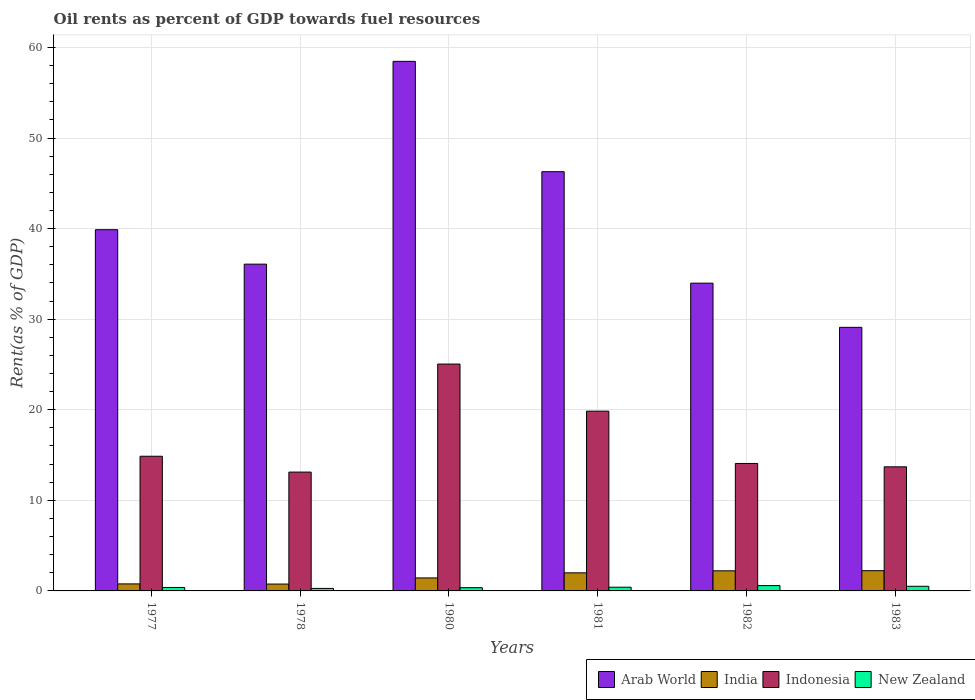Are the number of bars per tick equal to the number of legend labels?
Your answer should be very brief. Yes. How many bars are there on the 5th tick from the left?
Ensure brevity in your answer.  4. How many bars are there on the 4th tick from the right?
Your answer should be compact. 4. In how many cases, is the number of bars for a given year not equal to the number of legend labels?
Offer a very short reply. 0. What is the oil rent in Indonesia in 1982?
Provide a short and direct response. 14.07. Across all years, what is the maximum oil rent in India?
Ensure brevity in your answer.  2.23. Across all years, what is the minimum oil rent in Arab World?
Offer a very short reply. 29.1. In which year was the oil rent in Arab World maximum?
Offer a terse response. 1980. In which year was the oil rent in New Zealand minimum?
Provide a short and direct response. 1978. What is the total oil rent in New Zealand in the graph?
Give a very brief answer. 2.53. What is the difference between the oil rent in Indonesia in 1977 and that in 1980?
Offer a terse response. -10.18. What is the difference between the oil rent in India in 1981 and the oil rent in Arab World in 1982?
Your response must be concise. -31.98. What is the average oil rent in India per year?
Your response must be concise. 1.57. In the year 1978, what is the difference between the oil rent in New Zealand and oil rent in India?
Keep it short and to the point. -0.48. What is the ratio of the oil rent in Indonesia in 1978 to that in 1982?
Make the answer very short. 0.93. Is the oil rent in Arab World in 1977 less than that in 1978?
Your response must be concise. No. Is the difference between the oil rent in New Zealand in 1980 and 1982 greater than the difference between the oil rent in India in 1980 and 1982?
Ensure brevity in your answer.  Yes. What is the difference between the highest and the second highest oil rent in Arab World?
Ensure brevity in your answer.  12.18. What is the difference between the highest and the lowest oil rent in New Zealand?
Provide a succinct answer. 0.31. In how many years, is the oil rent in Indonesia greater than the average oil rent in Indonesia taken over all years?
Offer a very short reply. 2. Is it the case that in every year, the sum of the oil rent in Indonesia and oil rent in New Zealand is greater than the sum of oil rent in Arab World and oil rent in India?
Offer a terse response. Yes. What does the 4th bar from the left in 1983 represents?
Your answer should be very brief. New Zealand. What does the 2nd bar from the right in 1978 represents?
Your answer should be very brief. Indonesia. Is it the case that in every year, the sum of the oil rent in New Zealand and oil rent in India is greater than the oil rent in Indonesia?
Make the answer very short. No. Are all the bars in the graph horizontal?
Ensure brevity in your answer.  No. Are the values on the major ticks of Y-axis written in scientific E-notation?
Your answer should be very brief. No. Does the graph contain any zero values?
Offer a very short reply. No. How many legend labels are there?
Give a very brief answer. 4. How are the legend labels stacked?
Provide a short and direct response. Horizontal. What is the title of the graph?
Provide a succinct answer. Oil rents as percent of GDP towards fuel resources. Does "Kazakhstan" appear as one of the legend labels in the graph?
Make the answer very short. No. What is the label or title of the Y-axis?
Your answer should be very brief. Rent(as % of GDP). What is the Rent(as % of GDP) in Arab World in 1977?
Provide a short and direct response. 39.88. What is the Rent(as % of GDP) of India in 1977?
Your response must be concise. 0.77. What is the Rent(as % of GDP) of Indonesia in 1977?
Your answer should be compact. 14.87. What is the Rent(as % of GDP) in New Zealand in 1977?
Ensure brevity in your answer.  0.38. What is the Rent(as % of GDP) of Arab World in 1978?
Offer a very short reply. 36.08. What is the Rent(as % of GDP) in India in 1978?
Ensure brevity in your answer.  0.76. What is the Rent(as % of GDP) of Indonesia in 1978?
Your answer should be compact. 13.12. What is the Rent(as % of GDP) of New Zealand in 1978?
Offer a very short reply. 0.28. What is the Rent(as % of GDP) of Arab World in 1980?
Your response must be concise. 58.46. What is the Rent(as % of GDP) of India in 1980?
Offer a terse response. 1.43. What is the Rent(as % of GDP) in Indonesia in 1980?
Provide a short and direct response. 25.05. What is the Rent(as % of GDP) in New Zealand in 1980?
Provide a short and direct response. 0.36. What is the Rent(as % of GDP) in Arab World in 1981?
Offer a terse response. 46.28. What is the Rent(as % of GDP) in India in 1981?
Your response must be concise. 2. What is the Rent(as % of GDP) of Indonesia in 1981?
Ensure brevity in your answer.  19.85. What is the Rent(as % of GDP) in New Zealand in 1981?
Make the answer very short. 0.41. What is the Rent(as % of GDP) of Arab World in 1982?
Keep it short and to the point. 33.98. What is the Rent(as % of GDP) of India in 1982?
Your answer should be compact. 2.22. What is the Rent(as % of GDP) of Indonesia in 1982?
Make the answer very short. 14.07. What is the Rent(as % of GDP) of New Zealand in 1982?
Offer a terse response. 0.59. What is the Rent(as % of GDP) of Arab World in 1983?
Ensure brevity in your answer.  29.1. What is the Rent(as % of GDP) in India in 1983?
Keep it short and to the point. 2.23. What is the Rent(as % of GDP) of Indonesia in 1983?
Keep it short and to the point. 13.7. What is the Rent(as % of GDP) of New Zealand in 1983?
Your response must be concise. 0.51. Across all years, what is the maximum Rent(as % of GDP) of Arab World?
Your answer should be compact. 58.46. Across all years, what is the maximum Rent(as % of GDP) in India?
Give a very brief answer. 2.23. Across all years, what is the maximum Rent(as % of GDP) of Indonesia?
Your response must be concise. 25.05. Across all years, what is the maximum Rent(as % of GDP) in New Zealand?
Offer a terse response. 0.59. Across all years, what is the minimum Rent(as % of GDP) in Arab World?
Offer a terse response. 29.1. Across all years, what is the minimum Rent(as % of GDP) of India?
Your answer should be compact. 0.76. Across all years, what is the minimum Rent(as % of GDP) of Indonesia?
Provide a short and direct response. 13.12. Across all years, what is the minimum Rent(as % of GDP) of New Zealand?
Your answer should be very brief. 0.28. What is the total Rent(as % of GDP) of Arab World in the graph?
Give a very brief answer. 243.77. What is the total Rent(as % of GDP) in India in the graph?
Offer a terse response. 9.41. What is the total Rent(as % of GDP) in Indonesia in the graph?
Give a very brief answer. 100.65. What is the total Rent(as % of GDP) in New Zealand in the graph?
Provide a short and direct response. 2.53. What is the difference between the Rent(as % of GDP) in Arab World in 1977 and that in 1978?
Make the answer very short. 3.8. What is the difference between the Rent(as % of GDP) in India in 1977 and that in 1978?
Offer a very short reply. 0.02. What is the difference between the Rent(as % of GDP) in Indonesia in 1977 and that in 1978?
Your response must be concise. 1.75. What is the difference between the Rent(as % of GDP) of New Zealand in 1977 and that in 1978?
Make the answer very short. 0.11. What is the difference between the Rent(as % of GDP) of Arab World in 1977 and that in 1980?
Your answer should be compact. -18.58. What is the difference between the Rent(as % of GDP) in India in 1977 and that in 1980?
Provide a short and direct response. -0.66. What is the difference between the Rent(as % of GDP) of Indonesia in 1977 and that in 1980?
Make the answer very short. -10.18. What is the difference between the Rent(as % of GDP) of New Zealand in 1977 and that in 1980?
Offer a terse response. 0.02. What is the difference between the Rent(as % of GDP) of Arab World in 1977 and that in 1981?
Provide a succinct answer. -6.4. What is the difference between the Rent(as % of GDP) in India in 1977 and that in 1981?
Provide a short and direct response. -1.22. What is the difference between the Rent(as % of GDP) in Indonesia in 1977 and that in 1981?
Your answer should be very brief. -4.98. What is the difference between the Rent(as % of GDP) of New Zealand in 1977 and that in 1981?
Offer a terse response. -0.03. What is the difference between the Rent(as % of GDP) of Arab World in 1977 and that in 1982?
Provide a short and direct response. 5.9. What is the difference between the Rent(as % of GDP) in India in 1977 and that in 1982?
Your answer should be very brief. -1.44. What is the difference between the Rent(as % of GDP) in Indonesia in 1977 and that in 1982?
Offer a terse response. 0.8. What is the difference between the Rent(as % of GDP) in New Zealand in 1977 and that in 1982?
Offer a terse response. -0.21. What is the difference between the Rent(as % of GDP) in Arab World in 1977 and that in 1983?
Offer a very short reply. 10.78. What is the difference between the Rent(as % of GDP) of India in 1977 and that in 1983?
Provide a succinct answer. -1.46. What is the difference between the Rent(as % of GDP) of Indonesia in 1977 and that in 1983?
Offer a terse response. 1.17. What is the difference between the Rent(as % of GDP) in New Zealand in 1977 and that in 1983?
Offer a very short reply. -0.13. What is the difference between the Rent(as % of GDP) of Arab World in 1978 and that in 1980?
Your answer should be very brief. -22.39. What is the difference between the Rent(as % of GDP) of India in 1978 and that in 1980?
Offer a terse response. -0.68. What is the difference between the Rent(as % of GDP) in Indonesia in 1978 and that in 1980?
Offer a terse response. -11.93. What is the difference between the Rent(as % of GDP) of New Zealand in 1978 and that in 1980?
Offer a terse response. -0.08. What is the difference between the Rent(as % of GDP) of Arab World in 1978 and that in 1981?
Keep it short and to the point. -10.21. What is the difference between the Rent(as % of GDP) of India in 1978 and that in 1981?
Provide a succinct answer. -1.24. What is the difference between the Rent(as % of GDP) in Indonesia in 1978 and that in 1981?
Your answer should be compact. -6.73. What is the difference between the Rent(as % of GDP) in New Zealand in 1978 and that in 1981?
Provide a succinct answer. -0.13. What is the difference between the Rent(as % of GDP) in Arab World in 1978 and that in 1982?
Keep it short and to the point. 2.1. What is the difference between the Rent(as % of GDP) in India in 1978 and that in 1982?
Offer a very short reply. -1.46. What is the difference between the Rent(as % of GDP) in Indonesia in 1978 and that in 1982?
Make the answer very short. -0.95. What is the difference between the Rent(as % of GDP) of New Zealand in 1978 and that in 1982?
Your response must be concise. -0.31. What is the difference between the Rent(as % of GDP) in Arab World in 1978 and that in 1983?
Give a very brief answer. 6.98. What is the difference between the Rent(as % of GDP) in India in 1978 and that in 1983?
Ensure brevity in your answer.  -1.47. What is the difference between the Rent(as % of GDP) in Indonesia in 1978 and that in 1983?
Your answer should be very brief. -0.58. What is the difference between the Rent(as % of GDP) of New Zealand in 1978 and that in 1983?
Provide a succinct answer. -0.24. What is the difference between the Rent(as % of GDP) in Arab World in 1980 and that in 1981?
Your response must be concise. 12.18. What is the difference between the Rent(as % of GDP) of India in 1980 and that in 1981?
Your response must be concise. -0.56. What is the difference between the Rent(as % of GDP) of Indonesia in 1980 and that in 1981?
Offer a very short reply. 5.2. What is the difference between the Rent(as % of GDP) of New Zealand in 1980 and that in 1981?
Your answer should be compact. -0.05. What is the difference between the Rent(as % of GDP) of Arab World in 1980 and that in 1982?
Your answer should be very brief. 24.49. What is the difference between the Rent(as % of GDP) in India in 1980 and that in 1982?
Your answer should be very brief. -0.79. What is the difference between the Rent(as % of GDP) of Indonesia in 1980 and that in 1982?
Give a very brief answer. 10.97. What is the difference between the Rent(as % of GDP) in New Zealand in 1980 and that in 1982?
Make the answer very short. -0.23. What is the difference between the Rent(as % of GDP) in Arab World in 1980 and that in 1983?
Give a very brief answer. 29.36. What is the difference between the Rent(as % of GDP) in India in 1980 and that in 1983?
Offer a terse response. -0.8. What is the difference between the Rent(as % of GDP) in Indonesia in 1980 and that in 1983?
Offer a very short reply. 11.35. What is the difference between the Rent(as % of GDP) in New Zealand in 1980 and that in 1983?
Give a very brief answer. -0.15. What is the difference between the Rent(as % of GDP) of Arab World in 1981 and that in 1982?
Your response must be concise. 12.31. What is the difference between the Rent(as % of GDP) of India in 1981 and that in 1982?
Provide a short and direct response. -0.22. What is the difference between the Rent(as % of GDP) in Indonesia in 1981 and that in 1982?
Your response must be concise. 5.77. What is the difference between the Rent(as % of GDP) in New Zealand in 1981 and that in 1982?
Make the answer very short. -0.18. What is the difference between the Rent(as % of GDP) in Arab World in 1981 and that in 1983?
Provide a short and direct response. 17.18. What is the difference between the Rent(as % of GDP) of India in 1981 and that in 1983?
Give a very brief answer. -0.24. What is the difference between the Rent(as % of GDP) of Indonesia in 1981 and that in 1983?
Give a very brief answer. 6.14. What is the difference between the Rent(as % of GDP) in New Zealand in 1981 and that in 1983?
Give a very brief answer. -0.1. What is the difference between the Rent(as % of GDP) in Arab World in 1982 and that in 1983?
Offer a terse response. 4.88. What is the difference between the Rent(as % of GDP) of India in 1982 and that in 1983?
Ensure brevity in your answer.  -0.01. What is the difference between the Rent(as % of GDP) of Indonesia in 1982 and that in 1983?
Offer a very short reply. 0.37. What is the difference between the Rent(as % of GDP) in New Zealand in 1982 and that in 1983?
Your answer should be very brief. 0.08. What is the difference between the Rent(as % of GDP) in Arab World in 1977 and the Rent(as % of GDP) in India in 1978?
Your answer should be very brief. 39.12. What is the difference between the Rent(as % of GDP) of Arab World in 1977 and the Rent(as % of GDP) of Indonesia in 1978?
Make the answer very short. 26.76. What is the difference between the Rent(as % of GDP) of Arab World in 1977 and the Rent(as % of GDP) of New Zealand in 1978?
Make the answer very short. 39.6. What is the difference between the Rent(as % of GDP) of India in 1977 and the Rent(as % of GDP) of Indonesia in 1978?
Give a very brief answer. -12.35. What is the difference between the Rent(as % of GDP) in India in 1977 and the Rent(as % of GDP) in New Zealand in 1978?
Provide a succinct answer. 0.5. What is the difference between the Rent(as % of GDP) of Indonesia in 1977 and the Rent(as % of GDP) of New Zealand in 1978?
Offer a very short reply. 14.59. What is the difference between the Rent(as % of GDP) of Arab World in 1977 and the Rent(as % of GDP) of India in 1980?
Ensure brevity in your answer.  38.45. What is the difference between the Rent(as % of GDP) of Arab World in 1977 and the Rent(as % of GDP) of Indonesia in 1980?
Make the answer very short. 14.83. What is the difference between the Rent(as % of GDP) of Arab World in 1977 and the Rent(as % of GDP) of New Zealand in 1980?
Offer a very short reply. 39.52. What is the difference between the Rent(as % of GDP) in India in 1977 and the Rent(as % of GDP) in Indonesia in 1980?
Offer a terse response. -24.27. What is the difference between the Rent(as % of GDP) in India in 1977 and the Rent(as % of GDP) in New Zealand in 1980?
Your answer should be compact. 0.42. What is the difference between the Rent(as % of GDP) of Indonesia in 1977 and the Rent(as % of GDP) of New Zealand in 1980?
Offer a terse response. 14.51. What is the difference between the Rent(as % of GDP) of Arab World in 1977 and the Rent(as % of GDP) of India in 1981?
Offer a very short reply. 37.88. What is the difference between the Rent(as % of GDP) in Arab World in 1977 and the Rent(as % of GDP) in Indonesia in 1981?
Your response must be concise. 20.03. What is the difference between the Rent(as % of GDP) in Arab World in 1977 and the Rent(as % of GDP) in New Zealand in 1981?
Offer a very short reply. 39.47. What is the difference between the Rent(as % of GDP) of India in 1977 and the Rent(as % of GDP) of Indonesia in 1981?
Give a very brief answer. -19.07. What is the difference between the Rent(as % of GDP) in India in 1977 and the Rent(as % of GDP) in New Zealand in 1981?
Provide a short and direct response. 0.36. What is the difference between the Rent(as % of GDP) of Indonesia in 1977 and the Rent(as % of GDP) of New Zealand in 1981?
Make the answer very short. 14.46. What is the difference between the Rent(as % of GDP) in Arab World in 1977 and the Rent(as % of GDP) in India in 1982?
Your answer should be compact. 37.66. What is the difference between the Rent(as % of GDP) of Arab World in 1977 and the Rent(as % of GDP) of Indonesia in 1982?
Ensure brevity in your answer.  25.81. What is the difference between the Rent(as % of GDP) in Arab World in 1977 and the Rent(as % of GDP) in New Zealand in 1982?
Your answer should be compact. 39.29. What is the difference between the Rent(as % of GDP) of India in 1977 and the Rent(as % of GDP) of Indonesia in 1982?
Offer a very short reply. -13.3. What is the difference between the Rent(as % of GDP) in India in 1977 and the Rent(as % of GDP) in New Zealand in 1982?
Provide a succinct answer. 0.19. What is the difference between the Rent(as % of GDP) in Indonesia in 1977 and the Rent(as % of GDP) in New Zealand in 1982?
Make the answer very short. 14.28. What is the difference between the Rent(as % of GDP) in Arab World in 1977 and the Rent(as % of GDP) in India in 1983?
Provide a short and direct response. 37.65. What is the difference between the Rent(as % of GDP) of Arab World in 1977 and the Rent(as % of GDP) of Indonesia in 1983?
Your answer should be compact. 26.18. What is the difference between the Rent(as % of GDP) in Arab World in 1977 and the Rent(as % of GDP) in New Zealand in 1983?
Keep it short and to the point. 39.37. What is the difference between the Rent(as % of GDP) in India in 1977 and the Rent(as % of GDP) in Indonesia in 1983?
Keep it short and to the point. -12.93. What is the difference between the Rent(as % of GDP) of India in 1977 and the Rent(as % of GDP) of New Zealand in 1983?
Your answer should be very brief. 0.26. What is the difference between the Rent(as % of GDP) in Indonesia in 1977 and the Rent(as % of GDP) in New Zealand in 1983?
Provide a short and direct response. 14.36. What is the difference between the Rent(as % of GDP) in Arab World in 1978 and the Rent(as % of GDP) in India in 1980?
Make the answer very short. 34.64. What is the difference between the Rent(as % of GDP) in Arab World in 1978 and the Rent(as % of GDP) in Indonesia in 1980?
Your answer should be very brief. 11.03. What is the difference between the Rent(as % of GDP) of Arab World in 1978 and the Rent(as % of GDP) of New Zealand in 1980?
Provide a short and direct response. 35.72. What is the difference between the Rent(as % of GDP) in India in 1978 and the Rent(as % of GDP) in Indonesia in 1980?
Ensure brevity in your answer.  -24.29. What is the difference between the Rent(as % of GDP) in India in 1978 and the Rent(as % of GDP) in New Zealand in 1980?
Offer a very short reply. 0.4. What is the difference between the Rent(as % of GDP) of Indonesia in 1978 and the Rent(as % of GDP) of New Zealand in 1980?
Give a very brief answer. 12.76. What is the difference between the Rent(as % of GDP) of Arab World in 1978 and the Rent(as % of GDP) of India in 1981?
Make the answer very short. 34.08. What is the difference between the Rent(as % of GDP) in Arab World in 1978 and the Rent(as % of GDP) in Indonesia in 1981?
Offer a terse response. 16.23. What is the difference between the Rent(as % of GDP) in Arab World in 1978 and the Rent(as % of GDP) in New Zealand in 1981?
Offer a terse response. 35.66. What is the difference between the Rent(as % of GDP) of India in 1978 and the Rent(as % of GDP) of Indonesia in 1981?
Keep it short and to the point. -19.09. What is the difference between the Rent(as % of GDP) of India in 1978 and the Rent(as % of GDP) of New Zealand in 1981?
Provide a short and direct response. 0.35. What is the difference between the Rent(as % of GDP) in Indonesia in 1978 and the Rent(as % of GDP) in New Zealand in 1981?
Provide a succinct answer. 12.71. What is the difference between the Rent(as % of GDP) in Arab World in 1978 and the Rent(as % of GDP) in India in 1982?
Give a very brief answer. 33.86. What is the difference between the Rent(as % of GDP) in Arab World in 1978 and the Rent(as % of GDP) in Indonesia in 1982?
Offer a terse response. 22. What is the difference between the Rent(as % of GDP) in Arab World in 1978 and the Rent(as % of GDP) in New Zealand in 1982?
Offer a terse response. 35.49. What is the difference between the Rent(as % of GDP) in India in 1978 and the Rent(as % of GDP) in Indonesia in 1982?
Offer a terse response. -13.31. What is the difference between the Rent(as % of GDP) of India in 1978 and the Rent(as % of GDP) of New Zealand in 1982?
Offer a very short reply. 0.17. What is the difference between the Rent(as % of GDP) in Indonesia in 1978 and the Rent(as % of GDP) in New Zealand in 1982?
Your answer should be very brief. 12.53. What is the difference between the Rent(as % of GDP) in Arab World in 1978 and the Rent(as % of GDP) in India in 1983?
Keep it short and to the point. 33.84. What is the difference between the Rent(as % of GDP) of Arab World in 1978 and the Rent(as % of GDP) of Indonesia in 1983?
Make the answer very short. 22.37. What is the difference between the Rent(as % of GDP) in Arab World in 1978 and the Rent(as % of GDP) in New Zealand in 1983?
Give a very brief answer. 35.56. What is the difference between the Rent(as % of GDP) of India in 1978 and the Rent(as % of GDP) of Indonesia in 1983?
Provide a short and direct response. -12.94. What is the difference between the Rent(as % of GDP) in India in 1978 and the Rent(as % of GDP) in New Zealand in 1983?
Your answer should be very brief. 0.25. What is the difference between the Rent(as % of GDP) of Indonesia in 1978 and the Rent(as % of GDP) of New Zealand in 1983?
Offer a terse response. 12.61. What is the difference between the Rent(as % of GDP) of Arab World in 1980 and the Rent(as % of GDP) of India in 1981?
Keep it short and to the point. 56.47. What is the difference between the Rent(as % of GDP) of Arab World in 1980 and the Rent(as % of GDP) of Indonesia in 1981?
Give a very brief answer. 38.62. What is the difference between the Rent(as % of GDP) of Arab World in 1980 and the Rent(as % of GDP) of New Zealand in 1981?
Your response must be concise. 58.05. What is the difference between the Rent(as % of GDP) in India in 1980 and the Rent(as % of GDP) in Indonesia in 1981?
Your response must be concise. -18.41. What is the difference between the Rent(as % of GDP) in India in 1980 and the Rent(as % of GDP) in New Zealand in 1981?
Make the answer very short. 1.02. What is the difference between the Rent(as % of GDP) in Indonesia in 1980 and the Rent(as % of GDP) in New Zealand in 1981?
Give a very brief answer. 24.64. What is the difference between the Rent(as % of GDP) of Arab World in 1980 and the Rent(as % of GDP) of India in 1982?
Give a very brief answer. 56.24. What is the difference between the Rent(as % of GDP) of Arab World in 1980 and the Rent(as % of GDP) of Indonesia in 1982?
Give a very brief answer. 44.39. What is the difference between the Rent(as % of GDP) of Arab World in 1980 and the Rent(as % of GDP) of New Zealand in 1982?
Give a very brief answer. 57.88. What is the difference between the Rent(as % of GDP) in India in 1980 and the Rent(as % of GDP) in Indonesia in 1982?
Make the answer very short. -12.64. What is the difference between the Rent(as % of GDP) in India in 1980 and the Rent(as % of GDP) in New Zealand in 1982?
Give a very brief answer. 0.84. What is the difference between the Rent(as % of GDP) of Indonesia in 1980 and the Rent(as % of GDP) of New Zealand in 1982?
Keep it short and to the point. 24.46. What is the difference between the Rent(as % of GDP) in Arab World in 1980 and the Rent(as % of GDP) in India in 1983?
Offer a terse response. 56.23. What is the difference between the Rent(as % of GDP) in Arab World in 1980 and the Rent(as % of GDP) in Indonesia in 1983?
Provide a short and direct response. 44.76. What is the difference between the Rent(as % of GDP) of Arab World in 1980 and the Rent(as % of GDP) of New Zealand in 1983?
Offer a very short reply. 57.95. What is the difference between the Rent(as % of GDP) in India in 1980 and the Rent(as % of GDP) in Indonesia in 1983?
Your answer should be compact. -12.27. What is the difference between the Rent(as % of GDP) of India in 1980 and the Rent(as % of GDP) of New Zealand in 1983?
Your answer should be compact. 0.92. What is the difference between the Rent(as % of GDP) in Indonesia in 1980 and the Rent(as % of GDP) in New Zealand in 1983?
Your response must be concise. 24.53. What is the difference between the Rent(as % of GDP) in Arab World in 1981 and the Rent(as % of GDP) in India in 1982?
Ensure brevity in your answer.  44.06. What is the difference between the Rent(as % of GDP) in Arab World in 1981 and the Rent(as % of GDP) in Indonesia in 1982?
Keep it short and to the point. 32.21. What is the difference between the Rent(as % of GDP) of Arab World in 1981 and the Rent(as % of GDP) of New Zealand in 1982?
Make the answer very short. 45.69. What is the difference between the Rent(as % of GDP) of India in 1981 and the Rent(as % of GDP) of Indonesia in 1982?
Offer a very short reply. -12.07. What is the difference between the Rent(as % of GDP) of India in 1981 and the Rent(as % of GDP) of New Zealand in 1982?
Ensure brevity in your answer.  1.41. What is the difference between the Rent(as % of GDP) in Indonesia in 1981 and the Rent(as % of GDP) in New Zealand in 1982?
Keep it short and to the point. 19.26. What is the difference between the Rent(as % of GDP) in Arab World in 1981 and the Rent(as % of GDP) in India in 1983?
Keep it short and to the point. 44.05. What is the difference between the Rent(as % of GDP) in Arab World in 1981 and the Rent(as % of GDP) in Indonesia in 1983?
Ensure brevity in your answer.  32.58. What is the difference between the Rent(as % of GDP) in Arab World in 1981 and the Rent(as % of GDP) in New Zealand in 1983?
Your response must be concise. 45.77. What is the difference between the Rent(as % of GDP) of India in 1981 and the Rent(as % of GDP) of Indonesia in 1983?
Offer a terse response. -11.7. What is the difference between the Rent(as % of GDP) of India in 1981 and the Rent(as % of GDP) of New Zealand in 1983?
Your answer should be compact. 1.48. What is the difference between the Rent(as % of GDP) in Indonesia in 1981 and the Rent(as % of GDP) in New Zealand in 1983?
Your answer should be very brief. 19.33. What is the difference between the Rent(as % of GDP) of Arab World in 1982 and the Rent(as % of GDP) of India in 1983?
Offer a very short reply. 31.74. What is the difference between the Rent(as % of GDP) of Arab World in 1982 and the Rent(as % of GDP) of Indonesia in 1983?
Your answer should be compact. 20.28. What is the difference between the Rent(as % of GDP) in Arab World in 1982 and the Rent(as % of GDP) in New Zealand in 1983?
Make the answer very short. 33.46. What is the difference between the Rent(as % of GDP) of India in 1982 and the Rent(as % of GDP) of Indonesia in 1983?
Ensure brevity in your answer.  -11.48. What is the difference between the Rent(as % of GDP) in India in 1982 and the Rent(as % of GDP) in New Zealand in 1983?
Your response must be concise. 1.71. What is the difference between the Rent(as % of GDP) of Indonesia in 1982 and the Rent(as % of GDP) of New Zealand in 1983?
Provide a short and direct response. 13.56. What is the average Rent(as % of GDP) of Arab World per year?
Provide a short and direct response. 40.63. What is the average Rent(as % of GDP) in India per year?
Keep it short and to the point. 1.57. What is the average Rent(as % of GDP) in Indonesia per year?
Provide a succinct answer. 16.78. What is the average Rent(as % of GDP) of New Zealand per year?
Your response must be concise. 0.42. In the year 1977, what is the difference between the Rent(as % of GDP) of Arab World and Rent(as % of GDP) of India?
Keep it short and to the point. 39.1. In the year 1977, what is the difference between the Rent(as % of GDP) of Arab World and Rent(as % of GDP) of Indonesia?
Your answer should be very brief. 25.01. In the year 1977, what is the difference between the Rent(as % of GDP) in Arab World and Rent(as % of GDP) in New Zealand?
Your answer should be compact. 39.5. In the year 1977, what is the difference between the Rent(as % of GDP) in India and Rent(as % of GDP) in Indonesia?
Offer a very short reply. -14.09. In the year 1977, what is the difference between the Rent(as % of GDP) in India and Rent(as % of GDP) in New Zealand?
Your answer should be very brief. 0.39. In the year 1977, what is the difference between the Rent(as % of GDP) of Indonesia and Rent(as % of GDP) of New Zealand?
Provide a succinct answer. 14.49. In the year 1978, what is the difference between the Rent(as % of GDP) in Arab World and Rent(as % of GDP) in India?
Your response must be concise. 35.32. In the year 1978, what is the difference between the Rent(as % of GDP) of Arab World and Rent(as % of GDP) of Indonesia?
Offer a terse response. 22.96. In the year 1978, what is the difference between the Rent(as % of GDP) in Arab World and Rent(as % of GDP) in New Zealand?
Offer a terse response. 35.8. In the year 1978, what is the difference between the Rent(as % of GDP) of India and Rent(as % of GDP) of Indonesia?
Give a very brief answer. -12.36. In the year 1978, what is the difference between the Rent(as % of GDP) of India and Rent(as % of GDP) of New Zealand?
Offer a terse response. 0.48. In the year 1978, what is the difference between the Rent(as % of GDP) in Indonesia and Rent(as % of GDP) in New Zealand?
Ensure brevity in your answer.  12.84. In the year 1980, what is the difference between the Rent(as % of GDP) of Arab World and Rent(as % of GDP) of India?
Your answer should be very brief. 57.03. In the year 1980, what is the difference between the Rent(as % of GDP) of Arab World and Rent(as % of GDP) of Indonesia?
Provide a succinct answer. 33.42. In the year 1980, what is the difference between the Rent(as % of GDP) in Arab World and Rent(as % of GDP) in New Zealand?
Ensure brevity in your answer.  58.11. In the year 1980, what is the difference between the Rent(as % of GDP) in India and Rent(as % of GDP) in Indonesia?
Your response must be concise. -23.61. In the year 1980, what is the difference between the Rent(as % of GDP) of India and Rent(as % of GDP) of New Zealand?
Make the answer very short. 1.08. In the year 1980, what is the difference between the Rent(as % of GDP) in Indonesia and Rent(as % of GDP) in New Zealand?
Provide a short and direct response. 24.69. In the year 1981, what is the difference between the Rent(as % of GDP) in Arab World and Rent(as % of GDP) in India?
Offer a very short reply. 44.28. In the year 1981, what is the difference between the Rent(as % of GDP) of Arab World and Rent(as % of GDP) of Indonesia?
Offer a terse response. 26.44. In the year 1981, what is the difference between the Rent(as % of GDP) of Arab World and Rent(as % of GDP) of New Zealand?
Your response must be concise. 45.87. In the year 1981, what is the difference between the Rent(as % of GDP) of India and Rent(as % of GDP) of Indonesia?
Make the answer very short. -17.85. In the year 1981, what is the difference between the Rent(as % of GDP) in India and Rent(as % of GDP) in New Zealand?
Your answer should be compact. 1.59. In the year 1981, what is the difference between the Rent(as % of GDP) in Indonesia and Rent(as % of GDP) in New Zealand?
Give a very brief answer. 19.43. In the year 1982, what is the difference between the Rent(as % of GDP) of Arab World and Rent(as % of GDP) of India?
Provide a succinct answer. 31.76. In the year 1982, what is the difference between the Rent(as % of GDP) of Arab World and Rent(as % of GDP) of Indonesia?
Provide a short and direct response. 19.9. In the year 1982, what is the difference between the Rent(as % of GDP) of Arab World and Rent(as % of GDP) of New Zealand?
Offer a very short reply. 33.39. In the year 1982, what is the difference between the Rent(as % of GDP) of India and Rent(as % of GDP) of Indonesia?
Keep it short and to the point. -11.85. In the year 1982, what is the difference between the Rent(as % of GDP) of India and Rent(as % of GDP) of New Zealand?
Your response must be concise. 1.63. In the year 1982, what is the difference between the Rent(as % of GDP) of Indonesia and Rent(as % of GDP) of New Zealand?
Your answer should be compact. 13.48. In the year 1983, what is the difference between the Rent(as % of GDP) of Arab World and Rent(as % of GDP) of India?
Give a very brief answer. 26.87. In the year 1983, what is the difference between the Rent(as % of GDP) of Arab World and Rent(as % of GDP) of Indonesia?
Offer a very short reply. 15.4. In the year 1983, what is the difference between the Rent(as % of GDP) in Arab World and Rent(as % of GDP) in New Zealand?
Your response must be concise. 28.59. In the year 1983, what is the difference between the Rent(as % of GDP) in India and Rent(as % of GDP) in Indonesia?
Give a very brief answer. -11.47. In the year 1983, what is the difference between the Rent(as % of GDP) of India and Rent(as % of GDP) of New Zealand?
Offer a very short reply. 1.72. In the year 1983, what is the difference between the Rent(as % of GDP) of Indonesia and Rent(as % of GDP) of New Zealand?
Keep it short and to the point. 13.19. What is the ratio of the Rent(as % of GDP) of Arab World in 1977 to that in 1978?
Offer a terse response. 1.11. What is the ratio of the Rent(as % of GDP) in India in 1977 to that in 1978?
Make the answer very short. 1.02. What is the ratio of the Rent(as % of GDP) in Indonesia in 1977 to that in 1978?
Provide a succinct answer. 1.13. What is the ratio of the Rent(as % of GDP) in New Zealand in 1977 to that in 1978?
Provide a succinct answer. 1.38. What is the ratio of the Rent(as % of GDP) in Arab World in 1977 to that in 1980?
Offer a terse response. 0.68. What is the ratio of the Rent(as % of GDP) of India in 1977 to that in 1980?
Your answer should be very brief. 0.54. What is the ratio of the Rent(as % of GDP) in Indonesia in 1977 to that in 1980?
Provide a succinct answer. 0.59. What is the ratio of the Rent(as % of GDP) of New Zealand in 1977 to that in 1980?
Give a very brief answer. 1.07. What is the ratio of the Rent(as % of GDP) in Arab World in 1977 to that in 1981?
Your answer should be compact. 0.86. What is the ratio of the Rent(as % of GDP) in India in 1977 to that in 1981?
Offer a terse response. 0.39. What is the ratio of the Rent(as % of GDP) in Indonesia in 1977 to that in 1981?
Keep it short and to the point. 0.75. What is the ratio of the Rent(as % of GDP) of New Zealand in 1977 to that in 1981?
Keep it short and to the point. 0.93. What is the ratio of the Rent(as % of GDP) of Arab World in 1977 to that in 1982?
Offer a very short reply. 1.17. What is the ratio of the Rent(as % of GDP) of India in 1977 to that in 1982?
Your response must be concise. 0.35. What is the ratio of the Rent(as % of GDP) in Indonesia in 1977 to that in 1982?
Provide a succinct answer. 1.06. What is the ratio of the Rent(as % of GDP) of New Zealand in 1977 to that in 1982?
Give a very brief answer. 0.65. What is the ratio of the Rent(as % of GDP) in Arab World in 1977 to that in 1983?
Make the answer very short. 1.37. What is the ratio of the Rent(as % of GDP) in India in 1977 to that in 1983?
Provide a short and direct response. 0.35. What is the ratio of the Rent(as % of GDP) of Indonesia in 1977 to that in 1983?
Your answer should be compact. 1.09. What is the ratio of the Rent(as % of GDP) in New Zealand in 1977 to that in 1983?
Keep it short and to the point. 0.75. What is the ratio of the Rent(as % of GDP) in Arab World in 1978 to that in 1980?
Ensure brevity in your answer.  0.62. What is the ratio of the Rent(as % of GDP) of India in 1978 to that in 1980?
Provide a succinct answer. 0.53. What is the ratio of the Rent(as % of GDP) in Indonesia in 1978 to that in 1980?
Make the answer very short. 0.52. What is the ratio of the Rent(as % of GDP) in New Zealand in 1978 to that in 1980?
Give a very brief answer. 0.77. What is the ratio of the Rent(as % of GDP) of Arab World in 1978 to that in 1981?
Ensure brevity in your answer.  0.78. What is the ratio of the Rent(as % of GDP) in India in 1978 to that in 1981?
Make the answer very short. 0.38. What is the ratio of the Rent(as % of GDP) of Indonesia in 1978 to that in 1981?
Offer a terse response. 0.66. What is the ratio of the Rent(as % of GDP) in New Zealand in 1978 to that in 1981?
Ensure brevity in your answer.  0.67. What is the ratio of the Rent(as % of GDP) in Arab World in 1978 to that in 1982?
Ensure brevity in your answer.  1.06. What is the ratio of the Rent(as % of GDP) in India in 1978 to that in 1982?
Give a very brief answer. 0.34. What is the ratio of the Rent(as % of GDP) in Indonesia in 1978 to that in 1982?
Your answer should be very brief. 0.93. What is the ratio of the Rent(as % of GDP) in New Zealand in 1978 to that in 1982?
Your answer should be very brief. 0.47. What is the ratio of the Rent(as % of GDP) in Arab World in 1978 to that in 1983?
Your answer should be compact. 1.24. What is the ratio of the Rent(as % of GDP) of India in 1978 to that in 1983?
Offer a terse response. 0.34. What is the ratio of the Rent(as % of GDP) of Indonesia in 1978 to that in 1983?
Make the answer very short. 0.96. What is the ratio of the Rent(as % of GDP) in New Zealand in 1978 to that in 1983?
Offer a terse response. 0.54. What is the ratio of the Rent(as % of GDP) of Arab World in 1980 to that in 1981?
Keep it short and to the point. 1.26. What is the ratio of the Rent(as % of GDP) of India in 1980 to that in 1981?
Provide a succinct answer. 0.72. What is the ratio of the Rent(as % of GDP) in Indonesia in 1980 to that in 1981?
Make the answer very short. 1.26. What is the ratio of the Rent(as % of GDP) in New Zealand in 1980 to that in 1981?
Your answer should be very brief. 0.87. What is the ratio of the Rent(as % of GDP) in Arab World in 1980 to that in 1982?
Your answer should be compact. 1.72. What is the ratio of the Rent(as % of GDP) of India in 1980 to that in 1982?
Your response must be concise. 0.65. What is the ratio of the Rent(as % of GDP) of Indonesia in 1980 to that in 1982?
Keep it short and to the point. 1.78. What is the ratio of the Rent(as % of GDP) of New Zealand in 1980 to that in 1982?
Provide a short and direct response. 0.61. What is the ratio of the Rent(as % of GDP) in Arab World in 1980 to that in 1983?
Your response must be concise. 2.01. What is the ratio of the Rent(as % of GDP) of India in 1980 to that in 1983?
Offer a terse response. 0.64. What is the ratio of the Rent(as % of GDP) in Indonesia in 1980 to that in 1983?
Your answer should be compact. 1.83. What is the ratio of the Rent(as % of GDP) of New Zealand in 1980 to that in 1983?
Offer a very short reply. 0.7. What is the ratio of the Rent(as % of GDP) of Arab World in 1981 to that in 1982?
Keep it short and to the point. 1.36. What is the ratio of the Rent(as % of GDP) of India in 1981 to that in 1982?
Give a very brief answer. 0.9. What is the ratio of the Rent(as % of GDP) of Indonesia in 1981 to that in 1982?
Keep it short and to the point. 1.41. What is the ratio of the Rent(as % of GDP) of New Zealand in 1981 to that in 1982?
Provide a short and direct response. 0.7. What is the ratio of the Rent(as % of GDP) of Arab World in 1981 to that in 1983?
Your answer should be compact. 1.59. What is the ratio of the Rent(as % of GDP) of India in 1981 to that in 1983?
Your answer should be compact. 0.89. What is the ratio of the Rent(as % of GDP) in Indonesia in 1981 to that in 1983?
Provide a succinct answer. 1.45. What is the ratio of the Rent(as % of GDP) in New Zealand in 1981 to that in 1983?
Your answer should be very brief. 0.8. What is the ratio of the Rent(as % of GDP) of Arab World in 1982 to that in 1983?
Make the answer very short. 1.17. What is the ratio of the Rent(as % of GDP) in Indonesia in 1982 to that in 1983?
Offer a very short reply. 1.03. What is the ratio of the Rent(as % of GDP) of New Zealand in 1982 to that in 1983?
Keep it short and to the point. 1.15. What is the difference between the highest and the second highest Rent(as % of GDP) in Arab World?
Your response must be concise. 12.18. What is the difference between the highest and the second highest Rent(as % of GDP) of India?
Ensure brevity in your answer.  0.01. What is the difference between the highest and the second highest Rent(as % of GDP) in Indonesia?
Make the answer very short. 5.2. What is the difference between the highest and the second highest Rent(as % of GDP) in New Zealand?
Offer a very short reply. 0.08. What is the difference between the highest and the lowest Rent(as % of GDP) of Arab World?
Provide a succinct answer. 29.36. What is the difference between the highest and the lowest Rent(as % of GDP) in India?
Make the answer very short. 1.47. What is the difference between the highest and the lowest Rent(as % of GDP) in Indonesia?
Your answer should be compact. 11.93. What is the difference between the highest and the lowest Rent(as % of GDP) of New Zealand?
Provide a succinct answer. 0.31. 